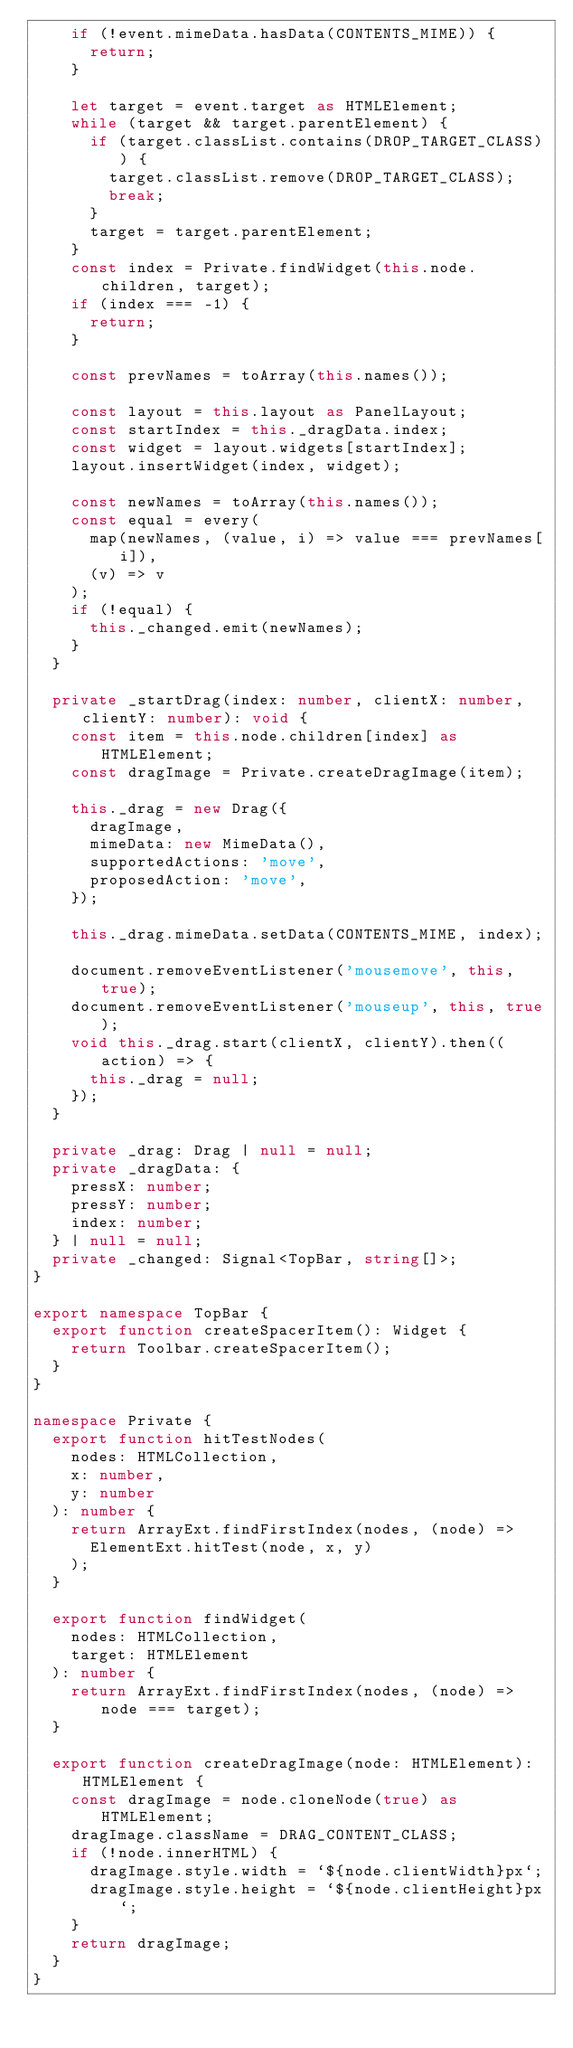Convert code to text. <code><loc_0><loc_0><loc_500><loc_500><_TypeScript_>    if (!event.mimeData.hasData(CONTENTS_MIME)) {
      return;
    }

    let target = event.target as HTMLElement;
    while (target && target.parentElement) {
      if (target.classList.contains(DROP_TARGET_CLASS)) {
        target.classList.remove(DROP_TARGET_CLASS);
        break;
      }
      target = target.parentElement;
    }
    const index = Private.findWidget(this.node.children, target);
    if (index === -1) {
      return;
    }

    const prevNames = toArray(this.names());

    const layout = this.layout as PanelLayout;
    const startIndex = this._dragData.index;
    const widget = layout.widgets[startIndex];
    layout.insertWidget(index, widget);

    const newNames = toArray(this.names());
    const equal = every(
      map(newNames, (value, i) => value === prevNames[i]),
      (v) => v
    );
    if (!equal) {
      this._changed.emit(newNames);
    }
  }

  private _startDrag(index: number, clientX: number, clientY: number): void {
    const item = this.node.children[index] as HTMLElement;
    const dragImage = Private.createDragImage(item);

    this._drag = new Drag({
      dragImage,
      mimeData: new MimeData(),
      supportedActions: 'move',
      proposedAction: 'move',
    });

    this._drag.mimeData.setData(CONTENTS_MIME, index);

    document.removeEventListener('mousemove', this, true);
    document.removeEventListener('mouseup', this, true);
    void this._drag.start(clientX, clientY).then((action) => {
      this._drag = null;
    });
  }

  private _drag: Drag | null = null;
  private _dragData: {
    pressX: number;
    pressY: number;
    index: number;
  } | null = null;
  private _changed: Signal<TopBar, string[]>;
}

export namespace TopBar {
  export function createSpacerItem(): Widget {
    return Toolbar.createSpacerItem();
  }
}

namespace Private {
  export function hitTestNodes(
    nodes: HTMLCollection,
    x: number,
    y: number
  ): number {
    return ArrayExt.findFirstIndex(nodes, (node) =>
      ElementExt.hitTest(node, x, y)
    );
  }

  export function findWidget(
    nodes: HTMLCollection,
    target: HTMLElement
  ): number {
    return ArrayExt.findFirstIndex(nodes, (node) => node === target);
  }

  export function createDragImage(node: HTMLElement): HTMLElement {
    const dragImage = node.cloneNode(true) as HTMLElement;
    dragImage.className = DRAG_CONTENT_CLASS;
    if (!node.innerHTML) {
      dragImage.style.width = `${node.clientWidth}px`;
      dragImage.style.height = `${node.clientHeight}px`;
    }
    return dragImage;
  }
}
</code> 